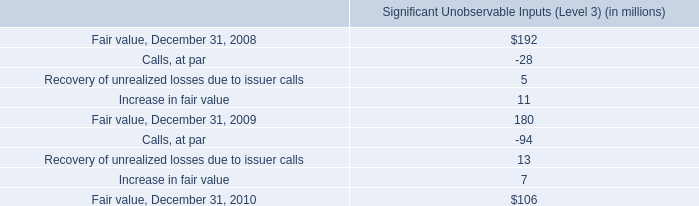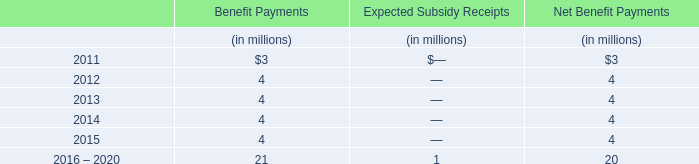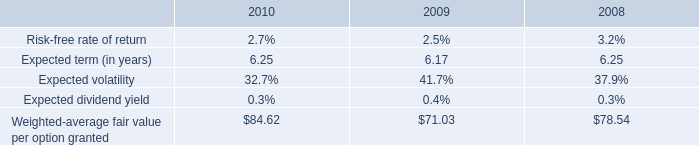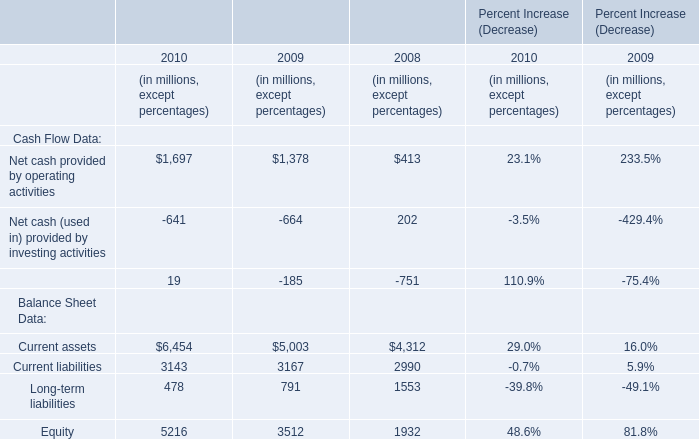What was the total amount of Cash Flow Data greater than 0 in 2010? (in millions) 
Computations: (1697 + 19)
Answer: 1716.0. 